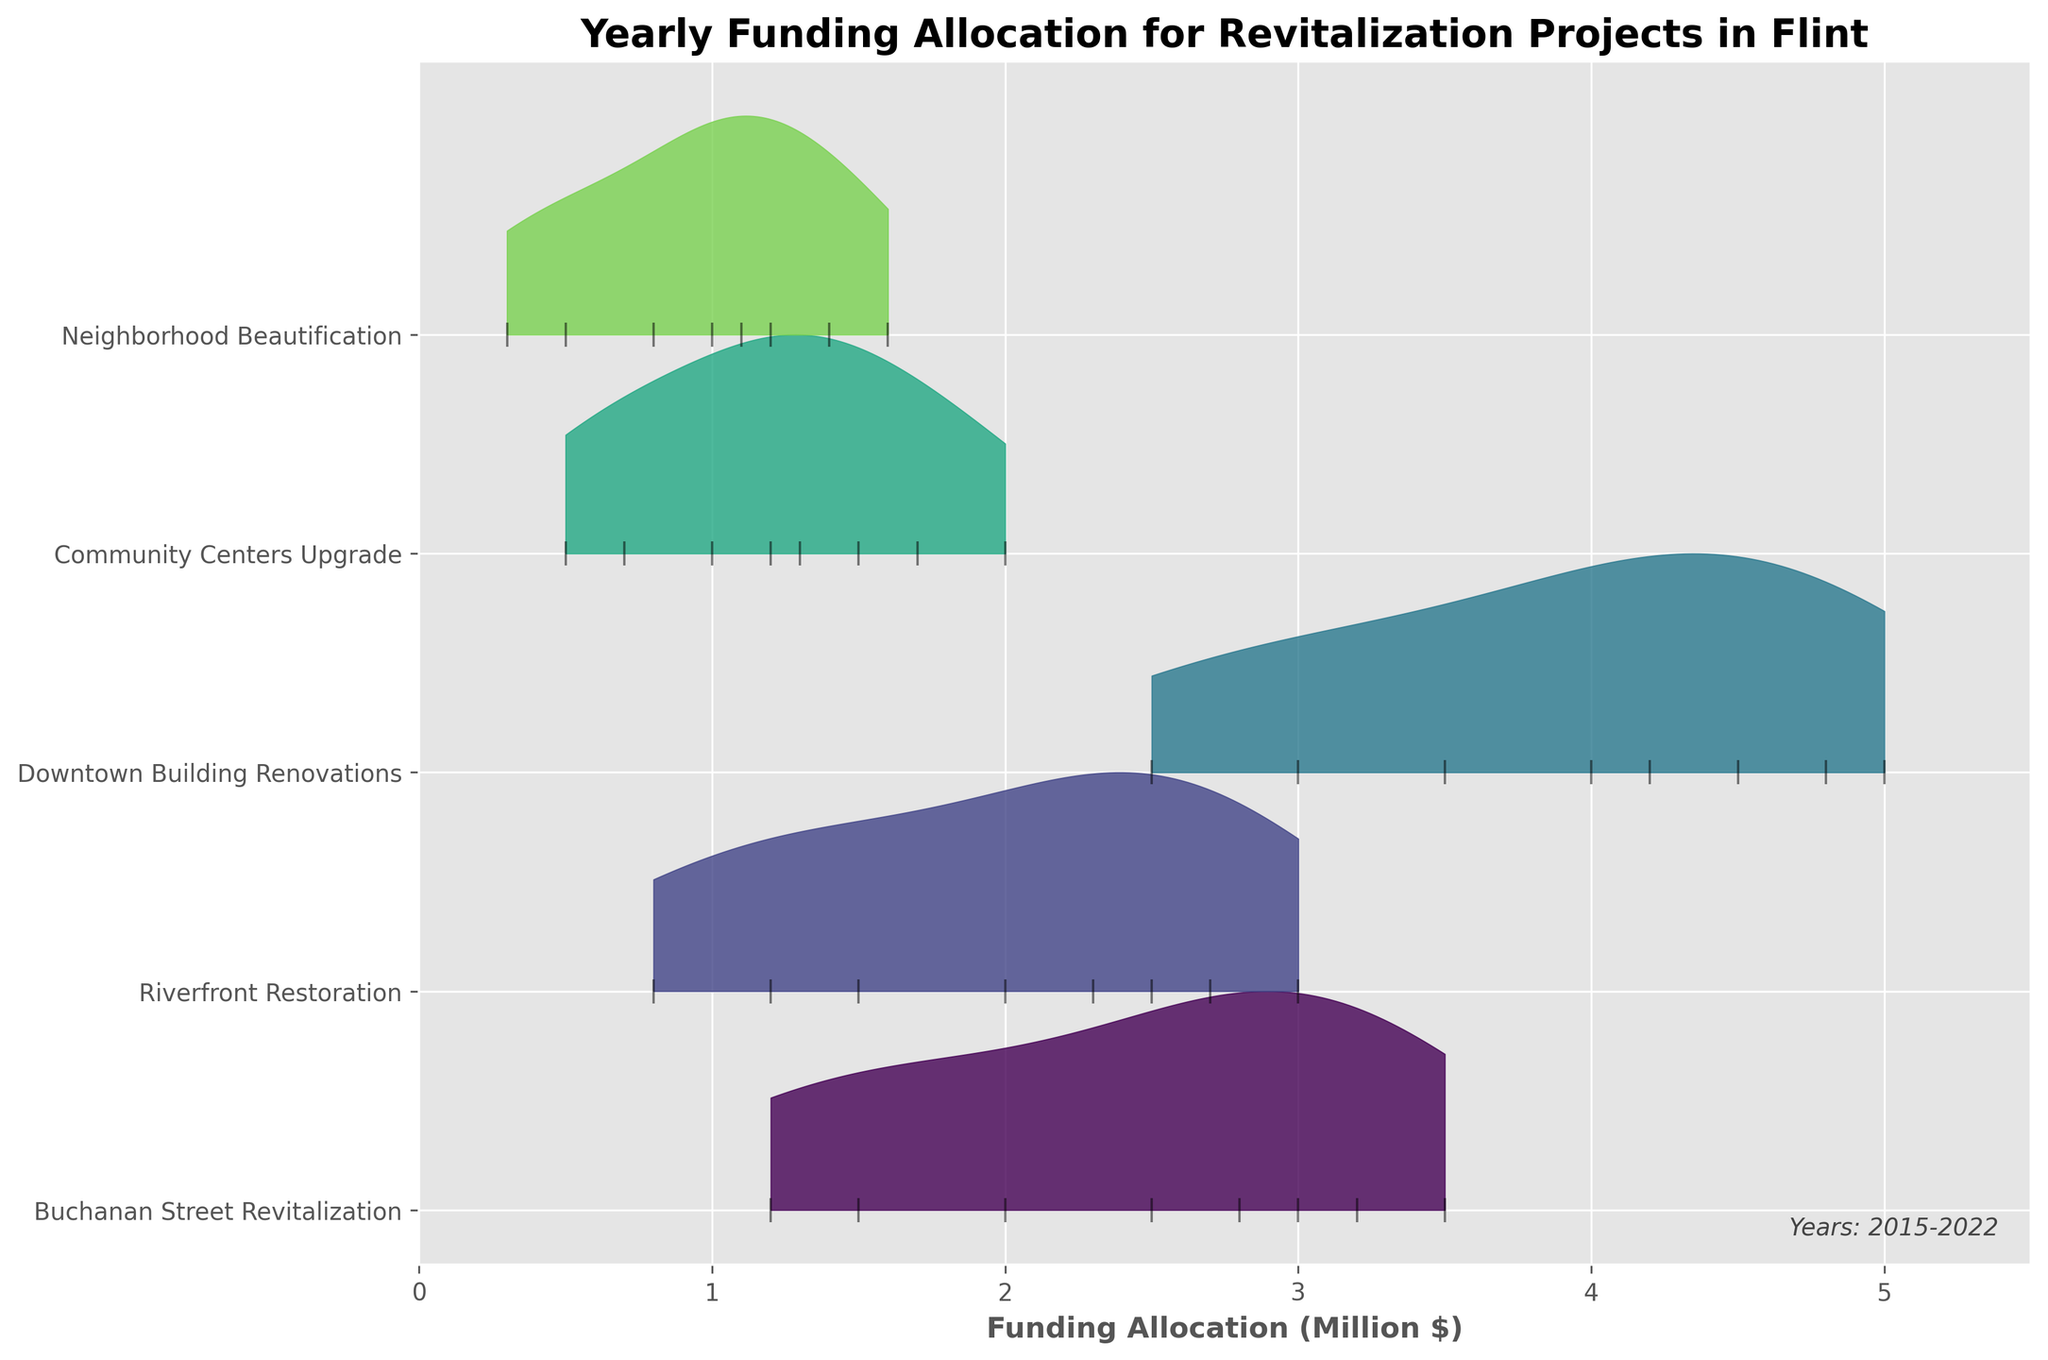Which project received the highest funding allocation in 2022? The title indicates the figure shows yearly funding for various revitalization projects. For 2022, the Downtown Building Renovations project has the highest peak on the x-axis.
Answer: Downtown Building Renovations How has the funding for the Riverfront Restoration project changed from 2015 to 2022? The Riverfront Restoration project shows a gradual increase from around 0.8 million in 2015 to 3.0 million in 2022.
Answer: Increased What is the range of funding allocation for Community Centers Upgrade across all years? By observing the figure, the minimum value for Community Centers Upgrade is 0.5 million in 2015 and the maximum is 2.0 million in 2022.
Answer: 0.5 to 2.0 million How does the funding for Neighborhood Beautification in 2015 compare to 2022? The funding for Neighborhood Beautification is much lower in 2015, around 0.3 million, whereas it increases to approximately 1.6 million by 2022.
Answer: Increased significantly What year did the funding for Buchanan Street Revitalization first exceed 2 million? The funding for Buchanan Street Revitalization first exceeds 2 million in 2017 according to the figure.
Answer: 2017 In which year did all projects see an increase in funding compared to the previous year? Inspecting the figure year by year, 2018 is the year where all projects depict an increase in funding from the previous year.
Answer: 2018 Which project shows the most consistent growth in funding over the years? The Downtown Building Renovations project demonstrates consistent year-on-year growth in funding, maintaining an upward trend from 2015 to 2022.
Answer: Downtown Building Renovations Has there been any year where the funding for Buchanan Street Revitalization decreased? From the figure, the funding for Buchanan Street Revitalization has not decreased in any year; it consistently increases or remains constant.
Answer: No Compare the funding allocations for Buchanan Street Revitalization and Riverfront Restoration in 2020. In 2020, Buchanan Street Revitalization received around 2.8 million, while Riverfront Restoration received about 2.3 million, making the former higher.
Answer: Buchanan Street Revitalization What's the total funding allocation for Downtown Building Renovations from 2015 to 2022? Summing the yearly allocations: 2.5 + 3.0 + 3.5 + 4.0 + 4.5 + 4.2 + 4.8 + 5.0 = 31.5 million.
Answer: 31.5 million 